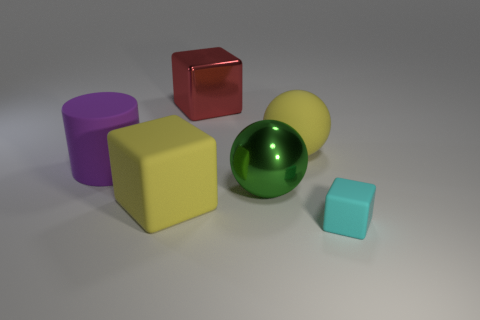Subtract all red metallic cubes. How many cubes are left? 2 Add 1 tiny brown metallic cylinders. How many objects exist? 7 Subtract all purple cubes. Subtract all brown spheres. How many cubes are left? 3 Subtract all balls. How many objects are left? 4 Subtract all big red shiny blocks. Subtract all rubber blocks. How many objects are left? 3 Add 5 cyan blocks. How many cyan blocks are left? 6 Add 2 red cubes. How many red cubes exist? 3 Subtract 0 gray balls. How many objects are left? 6 